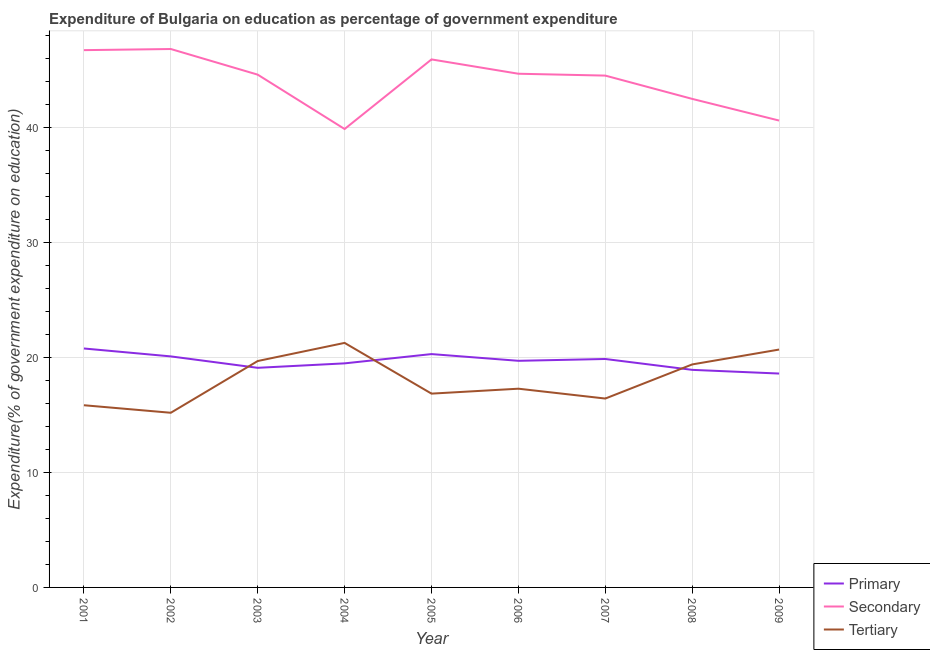What is the expenditure on secondary education in 2006?
Make the answer very short. 44.69. Across all years, what is the maximum expenditure on tertiary education?
Ensure brevity in your answer.  21.27. Across all years, what is the minimum expenditure on secondary education?
Give a very brief answer. 39.88. In which year was the expenditure on secondary education minimum?
Give a very brief answer. 2004. What is the total expenditure on tertiary education in the graph?
Your response must be concise. 162.69. What is the difference between the expenditure on primary education in 2003 and that in 2007?
Offer a terse response. -0.77. What is the difference between the expenditure on tertiary education in 2009 and the expenditure on primary education in 2002?
Your answer should be compact. 0.6. What is the average expenditure on tertiary education per year?
Ensure brevity in your answer.  18.08. In the year 2003, what is the difference between the expenditure on secondary education and expenditure on primary education?
Your response must be concise. 25.5. What is the ratio of the expenditure on primary education in 2004 to that in 2006?
Your answer should be very brief. 0.99. What is the difference between the highest and the second highest expenditure on secondary education?
Provide a short and direct response. 0.1. What is the difference between the highest and the lowest expenditure on tertiary education?
Ensure brevity in your answer.  6.08. Is the sum of the expenditure on secondary education in 2001 and 2007 greater than the maximum expenditure on primary education across all years?
Keep it short and to the point. Yes. Is it the case that in every year, the sum of the expenditure on primary education and expenditure on secondary education is greater than the expenditure on tertiary education?
Provide a succinct answer. Yes. Is the expenditure on tertiary education strictly less than the expenditure on primary education over the years?
Your answer should be very brief. No. How many lines are there?
Your answer should be very brief. 3. How many years are there in the graph?
Your response must be concise. 9. What is the difference between two consecutive major ticks on the Y-axis?
Ensure brevity in your answer.  10. Are the values on the major ticks of Y-axis written in scientific E-notation?
Give a very brief answer. No. Does the graph contain any zero values?
Your answer should be compact. No. Does the graph contain grids?
Provide a short and direct response. Yes. How many legend labels are there?
Offer a terse response. 3. What is the title of the graph?
Give a very brief answer. Expenditure of Bulgaria on education as percentage of government expenditure. What is the label or title of the X-axis?
Your answer should be very brief. Year. What is the label or title of the Y-axis?
Offer a very short reply. Expenditure(% of government expenditure on education). What is the Expenditure(% of government expenditure on education) in Primary in 2001?
Your answer should be compact. 20.79. What is the Expenditure(% of government expenditure on education) of Secondary in 2001?
Your answer should be very brief. 46.74. What is the Expenditure(% of government expenditure on education) of Tertiary in 2001?
Provide a succinct answer. 15.85. What is the Expenditure(% of government expenditure on education) in Primary in 2002?
Make the answer very short. 20.1. What is the Expenditure(% of government expenditure on education) in Secondary in 2002?
Provide a short and direct response. 46.84. What is the Expenditure(% of government expenditure on education) of Tertiary in 2002?
Make the answer very short. 15.19. What is the Expenditure(% of government expenditure on education) of Primary in 2003?
Give a very brief answer. 19.11. What is the Expenditure(% of government expenditure on education) of Secondary in 2003?
Give a very brief answer. 44.61. What is the Expenditure(% of government expenditure on education) of Tertiary in 2003?
Keep it short and to the point. 19.7. What is the Expenditure(% of government expenditure on education) in Primary in 2004?
Ensure brevity in your answer.  19.49. What is the Expenditure(% of government expenditure on education) in Secondary in 2004?
Make the answer very short. 39.88. What is the Expenditure(% of government expenditure on education) of Tertiary in 2004?
Keep it short and to the point. 21.27. What is the Expenditure(% of government expenditure on education) of Primary in 2005?
Offer a terse response. 20.3. What is the Expenditure(% of government expenditure on education) of Secondary in 2005?
Offer a very short reply. 45.94. What is the Expenditure(% of government expenditure on education) of Tertiary in 2005?
Keep it short and to the point. 16.86. What is the Expenditure(% of government expenditure on education) in Primary in 2006?
Your answer should be very brief. 19.72. What is the Expenditure(% of government expenditure on education) of Secondary in 2006?
Your answer should be very brief. 44.69. What is the Expenditure(% of government expenditure on education) of Tertiary in 2006?
Provide a short and direct response. 17.29. What is the Expenditure(% of government expenditure on education) in Primary in 2007?
Your answer should be compact. 19.87. What is the Expenditure(% of government expenditure on education) of Secondary in 2007?
Give a very brief answer. 44.53. What is the Expenditure(% of government expenditure on education) of Tertiary in 2007?
Offer a very short reply. 16.43. What is the Expenditure(% of government expenditure on education) in Primary in 2008?
Your answer should be very brief. 18.93. What is the Expenditure(% of government expenditure on education) in Secondary in 2008?
Your answer should be very brief. 42.5. What is the Expenditure(% of government expenditure on education) of Tertiary in 2008?
Offer a terse response. 19.4. What is the Expenditure(% of government expenditure on education) of Primary in 2009?
Your response must be concise. 18.61. What is the Expenditure(% of government expenditure on education) in Secondary in 2009?
Your response must be concise. 40.62. What is the Expenditure(% of government expenditure on education) of Tertiary in 2009?
Your response must be concise. 20.69. Across all years, what is the maximum Expenditure(% of government expenditure on education) in Primary?
Your answer should be very brief. 20.79. Across all years, what is the maximum Expenditure(% of government expenditure on education) of Secondary?
Your answer should be very brief. 46.84. Across all years, what is the maximum Expenditure(% of government expenditure on education) in Tertiary?
Your answer should be compact. 21.27. Across all years, what is the minimum Expenditure(% of government expenditure on education) in Primary?
Provide a short and direct response. 18.61. Across all years, what is the minimum Expenditure(% of government expenditure on education) in Secondary?
Give a very brief answer. 39.88. Across all years, what is the minimum Expenditure(% of government expenditure on education) of Tertiary?
Provide a short and direct response. 15.19. What is the total Expenditure(% of government expenditure on education) of Primary in the graph?
Provide a succinct answer. 176.91. What is the total Expenditure(% of government expenditure on education) in Secondary in the graph?
Give a very brief answer. 396.34. What is the total Expenditure(% of government expenditure on education) of Tertiary in the graph?
Offer a very short reply. 162.69. What is the difference between the Expenditure(% of government expenditure on education) of Primary in 2001 and that in 2002?
Give a very brief answer. 0.69. What is the difference between the Expenditure(% of government expenditure on education) in Secondary in 2001 and that in 2002?
Offer a terse response. -0.1. What is the difference between the Expenditure(% of government expenditure on education) in Tertiary in 2001 and that in 2002?
Offer a terse response. 0.66. What is the difference between the Expenditure(% of government expenditure on education) of Primary in 2001 and that in 2003?
Keep it short and to the point. 1.68. What is the difference between the Expenditure(% of government expenditure on education) in Secondary in 2001 and that in 2003?
Your answer should be very brief. 2.13. What is the difference between the Expenditure(% of government expenditure on education) in Tertiary in 2001 and that in 2003?
Offer a terse response. -3.85. What is the difference between the Expenditure(% of government expenditure on education) in Primary in 2001 and that in 2004?
Your response must be concise. 1.29. What is the difference between the Expenditure(% of government expenditure on education) in Secondary in 2001 and that in 2004?
Make the answer very short. 6.86. What is the difference between the Expenditure(% of government expenditure on education) of Tertiary in 2001 and that in 2004?
Your answer should be very brief. -5.42. What is the difference between the Expenditure(% of government expenditure on education) in Primary in 2001 and that in 2005?
Offer a very short reply. 0.49. What is the difference between the Expenditure(% of government expenditure on education) in Secondary in 2001 and that in 2005?
Ensure brevity in your answer.  0.81. What is the difference between the Expenditure(% of government expenditure on education) in Tertiary in 2001 and that in 2005?
Your answer should be compact. -1.01. What is the difference between the Expenditure(% of government expenditure on education) in Primary in 2001 and that in 2006?
Offer a very short reply. 1.07. What is the difference between the Expenditure(% of government expenditure on education) in Secondary in 2001 and that in 2006?
Provide a short and direct response. 2.05. What is the difference between the Expenditure(% of government expenditure on education) in Tertiary in 2001 and that in 2006?
Your response must be concise. -1.44. What is the difference between the Expenditure(% of government expenditure on education) of Primary in 2001 and that in 2007?
Offer a very short reply. 0.91. What is the difference between the Expenditure(% of government expenditure on education) in Secondary in 2001 and that in 2007?
Ensure brevity in your answer.  2.21. What is the difference between the Expenditure(% of government expenditure on education) of Tertiary in 2001 and that in 2007?
Your answer should be compact. -0.58. What is the difference between the Expenditure(% of government expenditure on education) of Primary in 2001 and that in 2008?
Your answer should be compact. 1.86. What is the difference between the Expenditure(% of government expenditure on education) of Secondary in 2001 and that in 2008?
Your response must be concise. 4.24. What is the difference between the Expenditure(% of government expenditure on education) in Tertiary in 2001 and that in 2008?
Offer a very short reply. -3.55. What is the difference between the Expenditure(% of government expenditure on education) in Primary in 2001 and that in 2009?
Make the answer very short. 2.18. What is the difference between the Expenditure(% of government expenditure on education) in Secondary in 2001 and that in 2009?
Your response must be concise. 6.13. What is the difference between the Expenditure(% of government expenditure on education) in Tertiary in 2001 and that in 2009?
Ensure brevity in your answer.  -4.84. What is the difference between the Expenditure(% of government expenditure on education) of Primary in 2002 and that in 2003?
Offer a very short reply. 0.99. What is the difference between the Expenditure(% of government expenditure on education) in Secondary in 2002 and that in 2003?
Offer a very short reply. 2.23. What is the difference between the Expenditure(% of government expenditure on education) in Tertiary in 2002 and that in 2003?
Offer a very short reply. -4.5. What is the difference between the Expenditure(% of government expenditure on education) in Primary in 2002 and that in 2004?
Offer a very short reply. 0.61. What is the difference between the Expenditure(% of government expenditure on education) of Secondary in 2002 and that in 2004?
Provide a succinct answer. 6.96. What is the difference between the Expenditure(% of government expenditure on education) in Tertiary in 2002 and that in 2004?
Offer a very short reply. -6.08. What is the difference between the Expenditure(% of government expenditure on education) of Primary in 2002 and that in 2005?
Your answer should be compact. -0.2. What is the difference between the Expenditure(% of government expenditure on education) of Secondary in 2002 and that in 2005?
Offer a very short reply. 0.9. What is the difference between the Expenditure(% of government expenditure on education) in Tertiary in 2002 and that in 2005?
Give a very brief answer. -1.67. What is the difference between the Expenditure(% of government expenditure on education) in Primary in 2002 and that in 2006?
Your answer should be very brief. 0.38. What is the difference between the Expenditure(% of government expenditure on education) of Secondary in 2002 and that in 2006?
Provide a succinct answer. 2.15. What is the difference between the Expenditure(% of government expenditure on education) in Tertiary in 2002 and that in 2006?
Offer a terse response. -2.09. What is the difference between the Expenditure(% of government expenditure on education) in Primary in 2002 and that in 2007?
Your answer should be compact. 0.23. What is the difference between the Expenditure(% of government expenditure on education) of Secondary in 2002 and that in 2007?
Make the answer very short. 2.31. What is the difference between the Expenditure(% of government expenditure on education) in Tertiary in 2002 and that in 2007?
Keep it short and to the point. -1.24. What is the difference between the Expenditure(% of government expenditure on education) in Primary in 2002 and that in 2008?
Your response must be concise. 1.17. What is the difference between the Expenditure(% of government expenditure on education) of Secondary in 2002 and that in 2008?
Make the answer very short. 4.34. What is the difference between the Expenditure(% of government expenditure on education) in Tertiary in 2002 and that in 2008?
Keep it short and to the point. -4.21. What is the difference between the Expenditure(% of government expenditure on education) in Primary in 2002 and that in 2009?
Your response must be concise. 1.49. What is the difference between the Expenditure(% of government expenditure on education) of Secondary in 2002 and that in 2009?
Your answer should be compact. 6.22. What is the difference between the Expenditure(% of government expenditure on education) of Tertiary in 2002 and that in 2009?
Give a very brief answer. -5.5. What is the difference between the Expenditure(% of government expenditure on education) of Primary in 2003 and that in 2004?
Your response must be concise. -0.39. What is the difference between the Expenditure(% of government expenditure on education) in Secondary in 2003 and that in 2004?
Offer a terse response. 4.73. What is the difference between the Expenditure(% of government expenditure on education) in Tertiary in 2003 and that in 2004?
Keep it short and to the point. -1.58. What is the difference between the Expenditure(% of government expenditure on education) in Primary in 2003 and that in 2005?
Give a very brief answer. -1.19. What is the difference between the Expenditure(% of government expenditure on education) in Secondary in 2003 and that in 2005?
Keep it short and to the point. -1.33. What is the difference between the Expenditure(% of government expenditure on education) of Tertiary in 2003 and that in 2005?
Give a very brief answer. 2.84. What is the difference between the Expenditure(% of government expenditure on education) in Primary in 2003 and that in 2006?
Provide a succinct answer. -0.61. What is the difference between the Expenditure(% of government expenditure on education) in Secondary in 2003 and that in 2006?
Make the answer very short. -0.08. What is the difference between the Expenditure(% of government expenditure on education) of Tertiary in 2003 and that in 2006?
Your response must be concise. 2.41. What is the difference between the Expenditure(% of government expenditure on education) in Primary in 2003 and that in 2007?
Keep it short and to the point. -0.77. What is the difference between the Expenditure(% of government expenditure on education) in Secondary in 2003 and that in 2007?
Keep it short and to the point. 0.08. What is the difference between the Expenditure(% of government expenditure on education) of Tertiary in 2003 and that in 2007?
Give a very brief answer. 3.26. What is the difference between the Expenditure(% of government expenditure on education) in Primary in 2003 and that in 2008?
Your response must be concise. 0.18. What is the difference between the Expenditure(% of government expenditure on education) in Secondary in 2003 and that in 2008?
Offer a very short reply. 2.11. What is the difference between the Expenditure(% of government expenditure on education) of Tertiary in 2003 and that in 2008?
Offer a terse response. 0.3. What is the difference between the Expenditure(% of government expenditure on education) of Primary in 2003 and that in 2009?
Provide a succinct answer. 0.5. What is the difference between the Expenditure(% of government expenditure on education) of Secondary in 2003 and that in 2009?
Provide a succinct answer. 3.99. What is the difference between the Expenditure(% of government expenditure on education) in Tertiary in 2003 and that in 2009?
Your answer should be very brief. -1. What is the difference between the Expenditure(% of government expenditure on education) of Primary in 2004 and that in 2005?
Your answer should be compact. -0.81. What is the difference between the Expenditure(% of government expenditure on education) of Secondary in 2004 and that in 2005?
Keep it short and to the point. -6.05. What is the difference between the Expenditure(% of government expenditure on education) in Tertiary in 2004 and that in 2005?
Ensure brevity in your answer.  4.41. What is the difference between the Expenditure(% of government expenditure on education) in Primary in 2004 and that in 2006?
Offer a very short reply. -0.22. What is the difference between the Expenditure(% of government expenditure on education) of Secondary in 2004 and that in 2006?
Keep it short and to the point. -4.81. What is the difference between the Expenditure(% of government expenditure on education) of Tertiary in 2004 and that in 2006?
Provide a short and direct response. 3.98. What is the difference between the Expenditure(% of government expenditure on education) of Primary in 2004 and that in 2007?
Keep it short and to the point. -0.38. What is the difference between the Expenditure(% of government expenditure on education) in Secondary in 2004 and that in 2007?
Provide a succinct answer. -4.65. What is the difference between the Expenditure(% of government expenditure on education) of Tertiary in 2004 and that in 2007?
Your answer should be very brief. 4.84. What is the difference between the Expenditure(% of government expenditure on education) of Primary in 2004 and that in 2008?
Offer a terse response. 0.56. What is the difference between the Expenditure(% of government expenditure on education) in Secondary in 2004 and that in 2008?
Your response must be concise. -2.62. What is the difference between the Expenditure(% of government expenditure on education) in Tertiary in 2004 and that in 2008?
Offer a terse response. 1.87. What is the difference between the Expenditure(% of government expenditure on education) in Primary in 2004 and that in 2009?
Your answer should be very brief. 0.89. What is the difference between the Expenditure(% of government expenditure on education) in Secondary in 2004 and that in 2009?
Provide a short and direct response. -0.74. What is the difference between the Expenditure(% of government expenditure on education) in Tertiary in 2004 and that in 2009?
Provide a succinct answer. 0.58. What is the difference between the Expenditure(% of government expenditure on education) of Primary in 2005 and that in 2006?
Provide a succinct answer. 0.58. What is the difference between the Expenditure(% of government expenditure on education) in Secondary in 2005 and that in 2006?
Keep it short and to the point. 1.25. What is the difference between the Expenditure(% of government expenditure on education) of Tertiary in 2005 and that in 2006?
Make the answer very short. -0.43. What is the difference between the Expenditure(% of government expenditure on education) of Primary in 2005 and that in 2007?
Offer a terse response. 0.43. What is the difference between the Expenditure(% of government expenditure on education) in Secondary in 2005 and that in 2007?
Keep it short and to the point. 1.41. What is the difference between the Expenditure(% of government expenditure on education) in Tertiary in 2005 and that in 2007?
Provide a succinct answer. 0.43. What is the difference between the Expenditure(% of government expenditure on education) in Primary in 2005 and that in 2008?
Provide a short and direct response. 1.37. What is the difference between the Expenditure(% of government expenditure on education) of Secondary in 2005 and that in 2008?
Keep it short and to the point. 3.43. What is the difference between the Expenditure(% of government expenditure on education) of Tertiary in 2005 and that in 2008?
Keep it short and to the point. -2.54. What is the difference between the Expenditure(% of government expenditure on education) in Primary in 2005 and that in 2009?
Ensure brevity in your answer.  1.69. What is the difference between the Expenditure(% of government expenditure on education) of Secondary in 2005 and that in 2009?
Provide a succinct answer. 5.32. What is the difference between the Expenditure(% of government expenditure on education) of Tertiary in 2005 and that in 2009?
Give a very brief answer. -3.83. What is the difference between the Expenditure(% of government expenditure on education) of Primary in 2006 and that in 2007?
Provide a short and direct response. -0.16. What is the difference between the Expenditure(% of government expenditure on education) in Secondary in 2006 and that in 2007?
Make the answer very short. 0.16. What is the difference between the Expenditure(% of government expenditure on education) in Tertiary in 2006 and that in 2007?
Ensure brevity in your answer.  0.86. What is the difference between the Expenditure(% of government expenditure on education) of Primary in 2006 and that in 2008?
Provide a short and direct response. 0.79. What is the difference between the Expenditure(% of government expenditure on education) in Secondary in 2006 and that in 2008?
Your response must be concise. 2.19. What is the difference between the Expenditure(% of government expenditure on education) of Tertiary in 2006 and that in 2008?
Offer a very short reply. -2.11. What is the difference between the Expenditure(% of government expenditure on education) of Primary in 2006 and that in 2009?
Keep it short and to the point. 1.11. What is the difference between the Expenditure(% of government expenditure on education) in Secondary in 2006 and that in 2009?
Your answer should be very brief. 4.07. What is the difference between the Expenditure(% of government expenditure on education) of Tertiary in 2006 and that in 2009?
Your answer should be compact. -3.41. What is the difference between the Expenditure(% of government expenditure on education) in Primary in 2007 and that in 2008?
Provide a short and direct response. 0.95. What is the difference between the Expenditure(% of government expenditure on education) of Secondary in 2007 and that in 2008?
Your answer should be compact. 2.03. What is the difference between the Expenditure(% of government expenditure on education) in Tertiary in 2007 and that in 2008?
Keep it short and to the point. -2.97. What is the difference between the Expenditure(% of government expenditure on education) of Primary in 2007 and that in 2009?
Your response must be concise. 1.27. What is the difference between the Expenditure(% of government expenditure on education) of Secondary in 2007 and that in 2009?
Offer a very short reply. 3.91. What is the difference between the Expenditure(% of government expenditure on education) of Tertiary in 2007 and that in 2009?
Ensure brevity in your answer.  -4.26. What is the difference between the Expenditure(% of government expenditure on education) of Primary in 2008 and that in 2009?
Keep it short and to the point. 0.32. What is the difference between the Expenditure(% of government expenditure on education) in Secondary in 2008 and that in 2009?
Provide a succinct answer. 1.89. What is the difference between the Expenditure(% of government expenditure on education) in Tertiary in 2008 and that in 2009?
Your answer should be very brief. -1.29. What is the difference between the Expenditure(% of government expenditure on education) of Primary in 2001 and the Expenditure(% of government expenditure on education) of Secondary in 2002?
Your response must be concise. -26.05. What is the difference between the Expenditure(% of government expenditure on education) in Primary in 2001 and the Expenditure(% of government expenditure on education) in Tertiary in 2002?
Provide a succinct answer. 5.59. What is the difference between the Expenditure(% of government expenditure on education) in Secondary in 2001 and the Expenditure(% of government expenditure on education) in Tertiary in 2002?
Provide a short and direct response. 31.55. What is the difference between the Expenditure(% of government expenditure on education) of Primary in 2001 and the Expenditure(% of government expenditure on education) of Secondary in 2003?
Your response must be concise. -23.82. What is the difference between the Expenditure(% of government expenditure on education) in Primary in 2001 and the Expenditure(% of government expenditure on education) in Tertiary in 2003?
Your answer should be compact. 1.09. What is the difference between the Expenditure(% of government expenditure on education) of Secondary in 2001 and the Expenditure(% of government expenditure on education) of Tertiary in 2003?
Offer a terse response. 27.05. What is the difference between the Expenditure(% of government expenditure on education) in Primary in 2001 and the Expenditure(% of government expenditure on education) in Secondary in 2004?
Your answer should be very brief. -19.09. What is the difference between the Expenditure(% of government expenditure on education) in Primary in 2001 and the Expenditure(% of government expenditure on education) in Tertiary in 2004?
Your answer should be very brief. -0.49. What is the difference between the Expenditure(% of government expenditure on education) of Secondary in 2001 and the Expenditure(% of government expenditure on education) of Tertiary in 2004?
Your response must be concise. 25.47. What is the difference between the Expenditure(% of government expenditure on education) in Primary in 2001 and the Expenditure(% of government expenditure on education) in Secondary in 2005?
Ensure brevity in your answer.  -25.15. What is the difference between the Expenditure(% of government expenditure on education) of Primary in 2001 and the Expenditure(% of government expenditure on education) of Tertiary in 2005?
Your response must be concise. 3.93. What is the difference between the Expenditure(% of government expenditure on education) in Secondary in 2001 and the Expenditure(% of government expenditure on education) in Tertiary in 2005?
Your answer should be very brief. 29.88. What is the difference between the Expenditure(% of government expenditure on education) in Primary in 2001 and the Expenditure(% of government expenditure on education) in Secondary in 2006?
Ensure brevity in your answer.  -23.9. What is the difference between the Expenditure(% of government expenditure on education) of Primary in 2001 and the Expenditure(% of government expenditure on education) of Tertiary in 2006?
Ensure brevity in your answer.  3.5. What is the difference between the Expenditure(% of government expenditure on education) of Secondary in 2001 and the Expenditure(% of government expenditure on education) of Tertiary in 2006?
Offer a very short reply. 29.45. What is the difference between the Expenditure(% of government expenditure on education) of Primary in 2001 and the Expenditure(% of government expenditure on education) of Secondary in 2007?
Your answer should be compact. -23.74. What is the difference between the Expenditure(% of government expenditure on education) in Primary in 2001 and the Expenditure(% of government expenditure on education) in Tertiary in 2007?
Provide a short and direct response. 4.36. What is the difference between the Expenditure(% of government expenditure on education) in Secondary in 2001 and the Expenditure(% of government expenditure on education) in Tertiary in 2007?
Keep it short and to the point. 30.31. What is the difference between the Expenditure(% of government expenditure on education) in Primary in 2001 and the Expenditure(% of government expenditure on education) in Secondary in 2008?
Offer a terse response. -21.71. What is the difference between the Expenditure(% of government expenditure on education) in Primary in 2001 and the Expenditure(% of government expenditure on education) in Tertiary in 2008?
Provide a succinct answer. 1.39. What is the difference between the Expenditure(% of government expenditure on education) of Secondary in 2001 and the Expenditure(% of government expenditure on education) of Tertiary in 2008?
Your answer should be very brief. 27.34. What is the difference between the Expenditure(% of government expenditure on education) of Primary in 2001 and the Expenditure(% of government expenditure on education) of Secondary in 2009?
Offer a terse response. -19.83. What is the difference between the Expenditure(% of government expenditure on education) of Primary in 2001 and the Expenditure(% of government expenditure on education) of Tertiary in 2009?
Offer a very short reply. 0.09. What is the difference between the Expenditure(% of government expenditure on education) in Secondary in 2001 and the Expenditure(% of government expenditure on education) in Tertiary in 2009?
Offer a very short reply. 26.05. What is the difference between the Expenditure(% of government expenditure on education) in Primary in 2002 and the Expenditure(% of government expenditure on education) in Secondary in 2003?
Keep it short and to the point. -24.51. What is the difference between the Expenditure(% of government expenditure on education) in Primary in 2002 and the Expenditure(% of government expenditure on education) in Tertiary in 2003?
Keep it short and to the point. 0.4. What is the difference between the Expenditure(% of government expenditure on education) in Secondary in 2002 and the Expenditure(% of government expenditure on education) in Tertiary in 2003?
Offer a very short reply. 27.14. What is the difference between the Expenditure(% of government expenditure on education) in Primary in 2002 and the Expenditure(% of government expenditure on education) in Secondary in 2004?
Your answer should be compact. -19.78. What is the difference between the Expenditure(% of government expenditure on education) in Primary in 2002 and the Expenditure(% of government expenditure on education) in Tertiary in 2004?
Make the answer very short. -1.17. What is the difference between the Expenditure(% of government expenditure on education) of Secondary in 2002 and the Expenditure(% of government expenditure on education) of Tertiary in 2004?
Ensure brevity in your answer.  25.57. What is the difference between the Expenditure(% of government expenditure on education) of Primary in 2002 and the Expenditure(% of government expenditure on education) of Secondary in 2005?
Give a very brief answer. -25.84. What is the difference between the Expenditure(% of government expenditure on education) of Primary in 2002 and the Expenditure(% of government expenditure on education) of Tertiary in 2005?
Your answer should be compact. 3.24. What is the difference between the Expenditure(% of government expenditure on education) of Secondary in 2002 and the Expenditure(% of government expenditure on education) of Tertiary in 2005?
Offer a terse response. 29.98. What is the difference between the Expenditure(% of government expenditure on education) in Primary in 2002 and the Expenditure(% of government expenditure on education) in Secondary in 2006?
Give a very brief answer. -24.59. What is the difference between the Expenditure(% of government expenditure on education) in Primary in 2002 and the Expenditure(% of government expenditure on education) in Tertiary in 2006?
Give a very brief answer. 2.81. What is the difference between the Expenditure(% of government expenditure on education) of Secondary in 2002 and the Expenditure(% of government expenditure on education) of Tertiary in 2006?
Your answer should be compact. 29.55. What is the difference between the Expenditure(% of government expenditure on education) in Primary in 2002 and the Expenditure(% of government expenditure on education) in Secondary in 2007?
Provide a succinct answer. -24.43. What is the difference between the Expenditure(% of government expenditure on education) in Primary in 2002 and the Expenditure(% of government expenditure on education) in Tertiary in 2007?
Provide a short and direct response. 3.67. What is the difference between the Expenditure(% of government expenditure on education) of Secondary in 2002 and the Expenditure(% of government expenditure on education) of Tertiary in 2007?
Provide a short and direct response. 30.41. What is the difference between the Expenditure(% of government expenditure on education) of Primary in 2002 and the Expenditure(% of government expenditure on education) of Secondary in 2008?
Your response must be concise. -22.4. What is the difference between the Expenditure(% of government expenditure on education) of Primary in 2002 and the Expenditure(% of government expenditure on education) of Tertiary in 2008?
Your response must be concise. 0.7. What is the difference between the Expenditure(% of government expenditure on education) in Secondary in 2002 and the Expenditure(% of government expenditure on education) in Tertiary in 2008?
Your response must be concise. 27.44. What is the difference between the Expenditure(% of government expenditure on education) in Primary in 2002 and the Expenditure(% of government expenditure on education) in Secondary in 2009?
Provide a succinct answer. -20.52. What is the difference between the Expenditure(% of government expenditure on education) of Primary in 2002 and the Expenditure(% of government expenditure on education) of Tertiary in 2009?
Provide a succinct answer. -0.6. What is the difference between the Expenditure(% of government expenditure on education) in Secondary in 2002 and the Expenditure(% of government expenditure on education) in Tertiary in 2009?
Your answer should be compact. 26.15. What is the difference between the Expenditure(% of government expenditure on education) in Primary in 2003 and the Expenditure(% of government expenditure on education) in Secondary in 2004?
Your answer should be compact. -20.77. What is the difference between the Expenditure(% of government expenditure on education) in Primary in 2003 and the Expenditure(% of government expenditure on education) in Tertiary in 2004?
Keep it short and to the point. -2.17. What is the difference between the Expenditure(% of government expenditure on education) of Secondary in 2003 and the Expenditure(% of government expenditure on education) of Tertiary in 2004?
Your answer should be compact. 23.34. What is the difference between the Expenditure(% of government expenditure on education) in Primary in 2003 and the Expenditure(% of government expenditure on education) in Secondary in 2005?
Keep it short and to the point. -26.83. What is the difference between the Expenditure(% of government expenditure on education) of Primary in 2003 and the Expenditure(% of government expenditure on education) of Tertiary in 2005?
Offer a terse response. 2.25. What is the difference between the Expenditure(% of government expenditure on education) in Secondary in 2003 and the Expenditure(% of government expenditure on education) in Tertiary in 2005?
Your answer should be very brief. 27.75. What is the difference between the Expenditure(% of government expenditure on education) in Primary in 2003 and the Expenditure(% of government expenditure on education) in Secondary in 2006?
Ensure brevity in your answer.  -25.58. What is the difference between the Expenditure(% of government expenditure on education) in Primary in 2003 and the Expenditure(% of government expenditure on education) in Tertiary in 2006?
Provide a short and direct response. 1.82. What is the difference between the Expenditure(% of government expenditure on education) in Secondary in 2003 and the Expenditure(% of government expenditure on education) in Tertiary in 2006?
Make the answer very short. 27.32. What is the difference between the Expenditure(% of government expenditure on education) in Primary in 2003 and the Expenditure(% of government expenditure on education) in Secondary in 2007?
Offer a terse response. -25.42. What is the difference between the Expenditure(% of government expenditure on education) in Primary in 2003 and the Expenditure(% of government expenditure on education) in Tertiary in 2007?
Offer a terse response. 2.67. What is the difference between the Expenditure(% of government expenditure on education) of Secondary in 2003 and the Expenditure(% of government expenditure on education) of Tertiary in 2007?
Offer a terse response. 28.18. What is the difference between the Expenditure(% of government expenditure on education) in Primary in 2003 and the Expenditure(% of government expenditure on education) in Secondary in 2008?
Make the answer very short. -23.4. What is the difference between the Expenditure(% of government expenditure on education) in Primary in 2003 and the Expenditure(% of government expenditure on education) in Tertiary in 2008?
Your response must be concise. -0.29. What is the difference between the Expenditure(% of government expenditure on education) in Secondary in 2003 and the Expenditure(% of government expenditure on education) in Tertiary in 2008?
Your answer should be compact. 25.21. What is the difference between the Expenditure(% of government expenditure on education) in Primary in 2003 and the Expenditure(% of government expenditure on education) in Secondary in 2009?
Provide a succinct answer. -21.51. What is the difference between the Expenditure(% of government expenditure on education) of Primary in 2003 and the Expenditure(% of government expenditure on education) of Tertiary in 2009?
Offer a terse response. -1.59. What is the difference between the Expenditure(% of government expenditure on education) of Secondary in 2003 and the Expenditure(% of government expenditure on education) of Tertiary in 2009?
Provide a succinct answer. 23.92. What is the difference between the Expenditure(% of government expenditure on education) in Primary in 2004 and the Expenditure(% of government expenditure on education) in Secondary in 2005?
Provide a succinct answer. -26.44. What is the difference between the Expenditure(% of government expenditure on education) in Primary in 2004 and the Expenditure(% of government expenditure on education) in Tertiary in 2005?
Make the answer very short. 2.63. What is the difference between the Expenditure(% of government expenditure on education) of Secondary in 2004 and the Expenditure(% of government expenditure on education) of Tertiary in 2005?
Provide a short and direct response. 23.02. What is the difference between the Expenditure(% of government expenditure on education) of Primary in 2004 and the Expenditure(% of government expenditure on education) of Secondary in 2006?
Ensure brevity in your answer.  -25.2. What is the difference between the Expenditure(% of government expenditure on education) in Primary in 2004 and the Expenditure(% of government expenditure on education) in Tertiary in 2006?
Provide a short and direct response. 2.2. What is the difference between the Expenditure(% of government expenditure on education) in Secondary in 2004 and the Expenditure(% of government expenditure on education) in Tertiary in 2006?
Make the answer very short. 22.59. What is the difference between the Expenditure(% of government expenditure on education) of Primary in 2004 and the Expenditure(% of government expenditure on education) of Secondary in 2007?
Offer a very short reply. -25.04. What is the difference between the Expenditure(% of government expenditure on education) in Primary in 2004 and the Expenditure(% of government expenditure on education) in Tertiary in 2007?
Give a very brief answer. 3.06. What is the difference between the Expenditure(% of government expenditure on education) in Secondary in 2004 and the Expenditure(% of government expenditure on education) in Tertiary in 2007?
Provide a short and direct response. 23.45. What is the difference between the Expenditure(% of government expenditure on education) of Primary in 2004 and the Expenditure(% of government expenditure on education) of Secondary in 2008?
Make the answer very short. -23.01. What is the difference between the Expenditure(% of government expenditure on education) in Primary in 2004 and the Expenditure(% of government expenditure on education) in Tertiary in 2008?
Ensure brevity in your answer.  0.09. What is the difference between the Expenditure(% of government expenditure on education) in Secondary in 2004 and the Expenditure(% of government expenditure on education) in Tertiary in 2008?
Your response must be concise. 20.48. What is the difference between the Expenditure(% of government expenditure on education) in Primary in 2004 and the Expenditure(% of government expenditure on education) in Secondary in 2009?
Offer a terse response. -21.12. What is the difference between the Expenditure(% of government expenditure on education) of Primary in 2004 and the Expenditure(% of government expenditure on education) of Tertiary in 2009?
Provide a succinct answer. -1.2. What is the difference between the Expenditure(% of government expenditure on education) of Secondary in 2004 and the Expenditure(% of government expenditure on education) of Tertiary in 2009?
Provide a short and direct response. 19.19. What is the difference between the Expenditure(% of government expenditure on education) of Primary in 2005 and the Expenditure(% of government expenditure on education) of Secondary in 2006?
Give a very brief answer. -24.39. What is the difference between the Expenditure(% of government expenditure on education) of Primary in 2005 and the Expenditure(% of government expenditure on education) of Tertiary in 2006?
Give a very brief answer. 3.01. What is the difference between the Expenditure(% of government expenditure on education) of Secondary in 2005 and the Expenditure(% of government expenditure on education) of Tertiary in 2006?
Offer a terse response. 28.65. What is the difference between the Expenditure(% of government expenditure on education) in Primary in 2005 and the Expenditure(% of government expenditure on education) in Secondary in 2007?
Provide a succinct answer. -24.23. What is the difference between the Expenditure(% of government expenditure on education) of Primary in 2005 and the Expenditure(% of government expenditure on education) of Tertiary in 2007?
Offer a terse response. 3.87. What is the difference between the Expenditure(% of government expenditure on education) in Secondary in 2005 and the Expenditure(% of government expenditure on education) in Tertiary in 2007?
Provide a succinct answer. 29.5. What is the difference between the Expenditure(% of government expenditure on education) in Primary in 2005 and the Expenditure(% of government expenditure on education) in Secondary in 2008?
Give a very brief answer. -22.2. What is the difference between the Expenditure(% of government expenditure on education) of Primary in 2005 and the Expenditure(% of government expenditure on education) of Tertiary in 2008?
Keep it short and to the point. 0.9. What is the difference between the Expenditure(% of government expenditure on education) of Secondary in 2005 and the Expenditure(% of government expenditure on education) of Tertiary in 2008?
Your response must be concise. 26.54. What is the difference between the Expenditure(% of government expenditure on education) of Primary in 2005 and the Expenditure(% of government expenditure on education) of Secondary in 2009?
Offer a terse response. -20.32. What is the difference between the Expenditure(% of government expenditure on education) of Primary in 2005 and the Expenditure(% of government expenditure on education) of Tertiary in 2009?
Your answer should be compact. -0.39. What is the difference between the Expenditure(% of government expenditure on education) in Secondary in 2005 and the Expenditure(% of government expenditure on education) in Tertiary in 2009?
Keep it short and to the point. 25.24. What is the difference between the Expenditure(% of government expenditure on education) in Primary in 2006 and the Expenditure(% of government expenditure on education) in Secondary in 2007?
Ensure brevity in your answer.  -24.81. What is the difference between the Expenditure(% of government expenditure on education) of Primary in 2006 and the Expenditure(% of government expenditure on education) of Tertiary in 2007?
Your answer should be compact. 3.28. What is the difference between the Expenditure(% of government expenditure on education) in Secondary in 2006 and the Expenditure(% of government expenditure on education) in Tertiary in 2007?
Your answer should be compact. 28.26. What is the difference between the Expenditure(% of government expenditure on education) in Primary in 2006 and the Expenditure(% of government expenditure on education) in Secondary in 2008?
Make the answer very short. -22.79. What is the difference between the Expenditure(% of government expenditure on education) of Primary in 2006 and the Expenditure(% of government expenditure on education) of Tertiary in 2008?
Offer a very short reply. 0.32. What is the difference between the Expenditure(% of government expenditure on education) of Secondary in 2006 and the Expenditure(% of government expenditure on education) of Tertiary in 2008?
Offer a terse response. 25.29. What is the difference between the Expenditure(% of government expenditure on education) in Primary in 2006 and the Expenditure(% of government expenditure on education) in Secondary in 2009?
Offer a terse response. -20.9. What is the difference between the Expenditure(% of government expenditure on education) in Primary in 2006 and the Expenditure(% of government expenditure on education) in Tertiary in 2009?
Ensure brevity in your answer.  -0.98. What is the difference between the Expenditure(% of government expenditure on education) in Secondary in 2006 and the Expenditure(% of government expenditure on education) in Tertiary in 2009?
Give a very brief answer. 23.99. What is the difference between the Expenditure(% of government expenditure on education) of Primary in 2007 and the Expenditure(% of government expenditure on education) of Secondary in 2008?
Provide a succinct answer. -22.63. What is the difference between the Expenditure(% of government expenditure on education) of Primary in 2007 and the Expenditure(% of government expenditure on education) of Tertiary in 2008?
Give a very brief answer. 0.47. What is the difference between the Expenditure(% of government expenditure on education) of Secondary in 2007 and the Expenditure(% of government expenditure on education) of Tertiary in 2008?
Your response must be concise. 25.13. What is the difference between the Expenditure(% of government expenditure on education) in Primary in 2007 and the Expenditure(% of government expenditure on education) in Secondary in 2009?
Ensure brevity in your answer.  -20.74. What is the difference between the Expenditure(% of government expenditure on education) of Primary in 2007 and the Expenditure(% of government expenditure on education) of Tertiary in 2009?
Provide a short and direct response. -0.82. What is the difference between the Expenditure(% of government expenditure on education) of Secondary in 2007 and the Expenditure(% of government expenditure on education) of Tertiary in 2009?
Your response must be concise. 23.83. What is the difference between the Expenditure(% of government expenditure on education) in Primary in 2008 and the Expenditure(% of government expenditure on education) in Secondary in 2009?
Your answer should be compact. -21.69. What is the difference between the Expenditure(% of government expenditure on education) in Primary in 2008 and the Expenditure(% of government expenditure on education) in Tertiary in 2009?
Keep it short and to the point. -1.77. What is the difference between the Expenditure(% of government expenditure on education) in Secondary in 2008 and the Expenditure(% of government expenditure on education) in Tertiary in 2009?
Your answer should be very brief. 21.81. What is the average Expenditure(% of government expenditure on education) in Primary per year?
Give a very brief answer. 19.66. What is the average Expenditure(% of government expenditure on education) in Secondary per year?
Your answer should be compact. 44.04. What is the average Expenditure(% of government expenditure on education) in Tertiary per year?
Keep it short and to the point. 18.08. In the year 2001, what is the difference between the Expenditure(% of government expenditure on education) in Primary and Expenditure(% of government expenditure on education) in Secondary?
Ensure brevity in your answer.  -25.96. In the year 2001, what is the difference between the Expenditure(% of government expenditure on education) in Primary and Expenditure(% of government expenditure on education) in Tertiary?
Keep it short and to the point. 4.94. In the year 2001, what is the difference between the Expenditure(% of government expenditure on education) of Secondary and Expenditure(% of government expenditure on education) of Tertiary?
Ensure brevity in your answer.  30.89. In the year 2002, what is the difference between the Expenditure(% of government expenditure on education) of Primary and Expenditure(% of government expenditure on education) of Secondary?
Provide a short and direct response. -26.74. In the year 2002, what is the difference between the Expenditure(% of government expenditure on education) in Primary and Expenditure(% of government expenditure on education) in Tertiary?
Give a very brief answer. 4.9. In the year 2002, what is the difference between the Expenditure(% of government expenditure on education) in Secondary and Expenditure(% of government expenditure on education) in Tertiary?
Make the answer very short. 31.65. In the year 2003, what is the difference between the Expenditure(% of government expenditure on education) of Primary and Expenditure(% of government expenditure on education) of Secondary?
Make the answer very short. -25.5. In the year 2003, what is the difference between the Expenditure(% of government expenditure on education) in Primary and Expenditure(% of government expenditure on education) in Tertiary?
Give a very brief answer. -0.59. In the year 2003, what is the difference between the Expenditure(% of government expenditure on education) in Secondary and Expenditure(% of government expenditure on education) in Tertiary?
Make the answer very short. 24.91. In the year 2004, what is the difference between the Expenditure(% of government expenditure on education) in Primary and Expenditure(% of government expenditure on education) in Secondary?
Offer a very short reply. -20.39. In the year 2004, what is the difference between the Expenditure(% of government expenditure on education) in Primary and Expenditure(% of government expenditure on education) in Tertiary?
Offer a very short reply. -1.78. In the year 2004, what is the difference between the Expenditure(% of government expenditure on education) of Secondary and Expenditure(% of government expenditure on education) of Tertiary?
Your answer should be compact. 18.61. In the year 2005, what is the difference between the Expenditure(% of government expenditure on education) in Primary and Expenditure(% of government expenditure on education) in Secondary?
Make the answer very short. -25.64. In the year 2005, what is the difference between the Expenditure(% of government expenditure on education) of Primary and Expenditure(% of government expenditure on education) of Tertiary?
Provide a short and direct response. 3.44. In the year 2005, what is the difference between the Expenditure(% of government expenditure on education) in Secondary and Expenditure(% of government expenditure on education) in Tertiary?
Your answer should be very brief. 29.08. In the year 2006, what is the difference between the Expenditure(% of government expenditure on education) of Primary and Expenditure(% of government expenditure on education) of Secondary?
Your answer should be very brief. -24.97. In the year 2006, what is the difference between the Expenditure(% of government expenditure on education) in Primary and Expenditure(% of government expenditure on education) in Tertiary?
Offer a very short reply. 2.43. In the year 2006, what is the difference between the Expenditure(% of government expenditure on education) in Secondary and Expenditure(% of government expenditure on education) in Tertiary?
Offer a terse response. 27.4. In the year 2007, what is the difference between the Expenditure(% of government expenditure on education) of Primary and Expenditure(% of government expenditure on education) of Secondary?
Offer a very short reply. -24.66. In the year 2007, what is the difference between the Expenditure(% of government expenditure on education) of Primary and Expenditure(% of government expenditure on education) of Tertiary?
Make the answer very short. 3.44. In the year 2007, what is the difference between the Expenditure(% of government expenditure on education) in Secondary and Expenditure(% of government expenditure on education) in Tertiary?
Your answer should be very brief. 28.1. In the year 2008, what is the difference between the Expenditure(% of government expenditure on education) of Primary and Expenditure(% of government expenditure on education) of Secondary?
Make the answer very short. -23.57. In the year 2008, what is the difference between the Expenditure(% of government expenditure on education) of Primary and Expenditure(% of government expenditure on education) of Tertiary?
Offer a very short reply. -0.47. In the year 2008, what is the difference between the Expenditure(% of government expenditure on education) in Secondary and Expenditure(% of government expenditure on education) in Tertiary?
Ensure brevity in your answer.  23.1. In the year 2009, what is the difference between the Expenditure(% of government expenditure on education) in Primary and Expenditure(% of government expenditure on education) in Secondary?
Your response must be concise. -22.01. In the year 2009, what is the difference between the Expenditure(% of government expenditure on education) of Primary and Expenditure(% of government expenditure on education) of Tertiary?
Make the answer very short. -2.09. In the year 2009, what is the difference between the Expenditure(% of government expenditure on education) of Secondary and Expenditure(% of government expenditure on education) of Tertiary?
Keep it short and to the point. 19.92. What is the ratio of the Expenditure(% of government expenditure on education) of Primary in 2001 to that in 2002?
Provide a succinct answer. 1.03. What is the ratio of the Expenditure(% of government expenditure on education) in Tertiary in 2001 to that in 2002?
Your answer should be compact. 1.04. What is the ratio of the Expenditure(% of government expenditure on education) of Primary in 2001 to that in 2003?
Offer a terse response. 1.09. What is the ratio of the Expenditure(% of government expenditure on education) of Secondary in 2001 to that in 2003?
Give a very brief answer. 1.05. What is the ratio of the Expenditure(% of government expenditure on education) of Tertiary in 2001 to that in 2003?
Keep it short and to the point. 0.8. What is the ratio of the Expenditure(% of government expenditure on education) in Primary in 2001 to that in 2004?
Offer a terse response. 1.07. What is the ratio of the Expenditure(% of government expenditure on education) in Secondary in 2001 to that in 2004?
Your answer should be compact. 1.17. What is the ratio of the Expenditure(% of government expenditure on education) in Tertiary in 2001 to that in 2004?
Offer a very short reply. 0.75. What is the ratio of the Expenditure(% of government expenditure on education) in Primary in 2001 to that in 2005?
Make the answer very short. 1.02. What is the ratio of the Expenditure(% of government expenditure on education) in Secondary in 2001 to that in 2005?
Ensure brevity in your answer.  1.02. What is the ratio of the Expenditure(% of government expenditure on education) of Tertiary in 2001 to that in 2005?
Offer a very short reply. 0.94. What is the ratio of the Expenditure(% of government expenditure on education) of Primary in 2001 to that in 2006?
Offer a terse response. 1.05. What is the ratio of the Expenditure(% of government expenditure on education) in Secondary in 2001 to that in 2006?
Offer a very short reply. 1.05. What is the ratio of the Expenditure(% of government expenditure on education) of Tertiary in 2001 to that in 2006?
Your answer should be compact. 0.92. What is the ratio of the Expenditure(% of government expenditure on education) in Primary in 2001 to that in 2007?
Offer a terse response. 1.05. What is the ratio of the Expenditure(% of government expenditure on education) of Secondary in 2001 to that in 2007?
Provide a succinct answer. 1.05. What is the ratio of the Expenditure(% of government expenditure on education) of Tertiary in 2001 to that in 2007?
Provide a short and direct response. 0.96. What is the ratio of the Expenditure(% of government expenditure on education) in Primary in 2001 to that in 2008?
Your answer should be compact. 1.1. What is the ratio of the Expenditure(% of government expenditure on education) in Secondary in 2001 to that in 2008?
Make the answer very short. 1.1. What is the ratio of the Expenditure(% of government expenditure on education) of Tertiary in 2001 to that in 2008?
Provide a short and direct response. 0.82. What is the ratio of the Expenditure(% of government expenditure on education) of Primary in 2001 to that in 2009?
Ensure brevity in your answer.  1.12. What is the ratio of the Expenditure(% of government expenditure on education) of Secondary in 2001 to that in 2009?
Your answer should be compact. 1.15. What is the ratio of the Expenditure(% of government expenditure on education) of Tertiary in 2001 to that in 2009?
Your response must be concise. 0.77. What is the ratio of the Expenditure(% of government expenditure on education) in Primary in 2002 to that in 2003?
Offer a terse response. 1.05. What is the ratio of the Expenditure(% of government expenditure on education) in Secondary in 2002 to that in 2003?
Offer a terse response. 1.05. What is the ratio of the Expenditure(% of government expenditure on education) in Tertiary in 2002 to that in 2003?
Provide a succinct answer. 0.77. What is the ratio of the Expenditure(% of government expenditure on education) of Primary in 2002 to that in 2004?
Offer a very short reply. 1.03. What is the ratio of the Expenditure(% of government expenditure on education) in Secondary in 2002 to that in 2004?
Keep it short and to the point. 1.17. What is the ratio of the Expenditure(% of government expenditure on education) in Tertiary in 2002 to that in 2004?
Keep it short and to the point. 0.71. What is the ratio of the Expenditure(% of government expenditure on education) of Primary in 2002 to that in 2005?
Ensure brevity in your answer.  0.99. What is the ratio of the Expenditure(% of government expenditure on education) of Secondary in 2002 to that in 2005?
Your answer should be very brief. 1.02. What is the ratio of the Expenditure(% of government expenditure on education) in Tertiary in 2002 to that in 2005?
Offer a terse response. 0.9. What is the ratio of the Expenditure(% of government expenditure on education) in Primary in 2002 to that in 2006?
Ensure brevity in your answer.  1.02. What is the ratio of the Expenditure(% of government expenditure on education) of Secondary in 2002 to that in 2006?
Provide a succinct answer. 1.05. What is the ratio of the Expenditure(% of government expenditure on education) of Tertiary in 2002 to that in 2006?
Provide a short and direct response. 0.88. What is the ratio of the Expenditure(% of government expenditure on education) in Primary in 2002 to that in 2007?
Make the answer very short. 1.01. What is the ratio of the Expenditure(% of government expenditure on education) in Secondary in 2002 to that in 2007?
Provide a short and direct response. 1.05. What is the ratio of the Expenditure(% of government expenditure on education) in Tertiary in 2002 to that in 2007?
Offer a very short reply. 0.92. What is the ratio of the Expenditure(% of government expenditure on education) of Primary in 2002 to that in 2008?
Keep it short and to the point. 1.06. What is the ratio of the Expenditure(% of government expenditure on education) of Secondary in 2002 to that in 2008?
Your answer should be compact. 1.1. What is the ratio of the Expenditure(% of government expenditure on education) in Tertiary in 2002 to that in 2008?
Your answer should be very brief. 0.78. What is the ratio of the Expenditure(% of government expenditure on education) of Primary in 2002 to that in 2009?
Ensure brevity in your answer.  1.08. What is the ratio of the Expenditure(% of government expenditure on education) in Secondary in 2002 to that in 2009?
Give a very brief answer. 1.15. What is the ratio of the Expenditure(% of government expenditure on education) of Tertiary in 2002 to that in 2009?
Make the answer very short. 0.73. What is the ratio of the Expenditure(% of government expenditure on education) of Primary in 2003 to that in 2004?
Make the answer very short. 0.98. What is the ratio of the Expenditure(% of government expenditure on education) in Secondary in 2003 to that in 2004?
Your answer should be compact. 1.12. What is the ratio of the Expenditure(% of government expenditure on education) in Tertiary in 2003 to that in 2004?
Offer a very short reply. 0.93. What is the ratio of the Expenditure(% of government expenditure on education) in Primary in 2003 to that in 2005?
Your answer should be very brief. 0.94. What is the ratio of the Expenditure(% of government expenditure on education) in Secondary in 2003 to that in 2005?
Provide a short and direct response. 0.97. What is the ratio of the Expenditure(% of government expenditure on education) in Tertiary in 2003 to that in 2005?
Your response must be concise. 1.17. What is the ratio of the Expenditure(% of government expenditure on education) of Primary in 2003 to that in 2006?
Offer a terse response. 0.97. What is the ratio of the Expenditure(% of government expenditure on education) in Secondary in 2003 to that in 2006?
Provide a succinct answer. 1. What is the ratio of the Expenditure(% of government expenditure on education) of Tertiary in 2003 to that in 2006?
Give a very brief answer. 1.14. What is the ratio of the Expenditure(% of government expenditure on education) of Primary in 2003 to that in 2007?
Keep it short and to the point. 0.96. What is the ratio of the Expenditure(% of government expenditure on education) in Secondary in 2003 to that in 2007?
Make the answer very short. 1. What is the ratio of the Expenditure(% of government expenditure on education) in Tertiary in 2003 to that in 2007?
Offer a terse response. 1.2. What is the ratio of the Expenditure(% of government expenditure on education) in Primary in 2003 to that in 2008?
Provide a short and direct response. 1.01. What is the ratio of the Expenditure(% of government expenditure on education) of Secondary in 2003 to that in 2008?
Ensure brevity in your answer.  1.05. What is the ratio of the Expenditure(% of government expenditure on education) in Tertiary in 2003 to that in 2008?
Ensure brevity in your answer.  1.02. What is the ratio of the Expenditure(% of government expenditure on education) in Primary in 2003 to that in 2009?
Keep it short and to the point. 1.03. What is the ratio of the Expenditure(% of government expenditure on education) in Secondary in 2003 to that in 2009?
Offer a very short reply. 1.1. What is the ratio of the Expenditure(% of government expenditure on education) in Tertiary in 2003 to that in 2009?
Give a very brief answer. 0.95. What is the ratio of the Expenditure(% of government expenditure on education) in Primary in 2004 to that in 2005?
Give a very brief answer. 0.96. What is the ratio of the Expenditure(% of government expenditure on education) of Secondary in 2004 to that in 2005?
Your response must be concise. 0.87. What is the ratio of the Expenditure(% of government expenditure on education) of Tertiary in 2004 to that in 2005?
Your response must be concise. 1.26. What is the ratio of the Expenditure(% of government expenditure on education) in Primary in 2004 to that in 2006?
Offer a terse response. 0.99. What is the ratio of the Expenditure(% of government expenditure on education) in Secondary in 2004 to that in 2006?
Provide a short and direct response. 0.89. What is the ratio of the Expenditure(% of government expenditure on education) in Tertiary in 2004 to that in 2006?
Provide a succinct answer. 1.23. What is the ratio of the Expenditure(% of government expenditure on education) in Primary in 2004 to that in 2007?
Offer a terse response. 0.98. What is the ratio of the Expenditure(% of government expenditure on education) in Secondary in 2004 to that in 2007?
Provide a short and direct response. 0.9. What is the ratio of the Expenditure(% of government expenditure on education) in Tertiary in 2004 to that in 2007?
Your response must be concise. 1.29. What is the ratio of the Expenditure(% of government expenditure on education) in Primary in 2004 to that in 2008?
Give a very brief answer. 1.03. What is the ratio of the Expenditure(% of government expenditure on education) in Secondary in 2004 to that in 2008?
Make the answer very short. 0.94. What is the ratio of the Expenditure(% of government expenditure on education) of Tertiary in 2004 to that in 2008?
Your response must be concise. 1.1. What is the ratio of the Expenditure(% of government expenditure on education) of Primary in 2004 to that in 2009?
Offer a terse response. 1.05. What is the ratio of the Expenditure(% of government expenditure on education) in Secondary in 2004 to that in 2009?
Your answer should be compact. 0.98. What is the ratio of the Expenditure(% of government expenditure on education) of Tertiary in 2004 to that in 2009?
Provide a short and direct response. 1.03. What is the ratio of the Expenditure(% of government expenditure on education) of Primary in 2005 to that in 2006?
Your answer should be compact. 1.03. What is the ratio of the Expenditure(% of government expenditure on education) in Secondary in 2005 to that in 2006?
Your response must be concise. 1.03. What is the ratio of the Expenditure(% of government expenditure on education) of Tertiary in 2005 to that in 2006?
Offer a very short reply. 0.98. What is the ratio of the Expenditure(% of government expenditure on education) in Primary in 2005 to that in 2007?
Your answer should be very brief. 1.02. What is the ratio of the Expenditure(% of government expenditure on education) of Secondary in 2005 to that in 2007?
Provide a succinct answer. 1.03. What is the ratio of the Expenditure(% of government expenditure on education) of Tertiary in 2005 to that in 2007?
Ensure brevity in your answer.  1.03. What is the ratio of the Expenditure(% of government expenditure on education) of Primary in 2005 to that in 2008?
Offer a terse response. 1.07. What is the ratio of the Expenditure(% of government expenditure on education) of Secondary in 2005 to that in 2008?
Provide a succinct answer. 1.08. What is the ratio of the Expenditure(% of government expenditure on education) in Tertiary in 2005 to that in 2008?
Give a very brief answer. 0.87. What is the ratio of the Expenditure(% of government expenditure on education) of Primary in 2005 to that in 2009?
Ensure brevity in your answer.  1.09. What is the ratio of the Expenditure(% of government expenditure on education) of Secondary in 2005 to that in 2009?
Keep it short and to the point. 1.13. What is the ratio of the Expenditure(% of government expenditure on education) in Tertiary in 2005 to that in 2009?
Your answer should be very brief. 0.81. What is the ratio of the Expenditure(% of government expenditure on education) in Primary in 2006 to that in 2007?
Offer a terse response. 0.99. What is the ratio of the Expenditure(% of government expenditure on education) of Tertiary in 2006 to that in 2007?
Keep it short and to the point. 1.05. What is the ratio of the Expenditure(% of government expenditure on education) in Primary in 2006 to that in 2008?
Your answer should be compact. 1.04. What is the ratio of the Expenditure(% of government expenditure on education) in Secondary in 2006 to that in 2008?
Offer a terse response. 1.05. What is the ratio of the Expenditure(% of government expenditure on education) in Tertiary in 2006 to that in 2008?
Your answer should be compact. 0.89. What is the ratio of the Expenditure(% of government expenditure on education) in Primary in 2006 to that in 2009?
Offer a terse response. 1.06. What is the ratio of the Expenditure(% of government expenditure on education) in Secondary in 2006 to that in 2009?
Ensure brevity in your answer.  1.1. What is the ratio of the Expenditure(% of government expenditure on education) in Tertiary in 2006 to that in 2009?
Provide a short and direct response. 0.84. What is the ratio of the Expenditure(% of government expenditure on education) of Primary in 2007 to that in 2008?
Give a very brief answer. 1.05. What is the ratio of the Expenditure(% of government expenditure on education) in Secondary in 2007 to that in 2008?
Provide a succinct answer. 1.05. What is the ratio of the Expenditure(% of government expenditure on education) in Tertiary in 2007 to that in 2008?
Offer a terse response. 0.85. What is the ratio of the Expenditure(% of government expenditure on education) of Primary in 2007 to that in 2009?
Your answer should be compact. 1.07. What is the ratio of the Expenditure(% of government expenditure on education) in Secondary in 2007 to that in 2009?
Provide a succinct answer. 1.1. What is the ratio of the Expenditure(% of government expenditure on education) of Tertiary in 2007 to that in 2009?
Make the answer very short. 0.79. What is the ratio of the Expenditure(% of government expenditure on education) in Primary in 2008 to that in 2009?
Your response must be concise. 1.02. What is the ratio of the Expenditure(% of government expenditure on education) in Secondary in 2008 to that in 2009?
Your response must be concise. 1.05. What is the difference between the highest and the second highest Expenditure(% of government expenditure on education) of Primary?
Your answer should be compact. 0.49. What is the difference between the highest and the second highest Expenditure(% of government expenditure on education) of Secondary?
Make the answer very short. 0.1. What is the difference between the highest and the second highest Expenditure(% of government expenditure on education) in Tertiary?
Offer a very short reply. 0.58. What is the difference between the highest and the lowest Expenditure(% of government expenditure on education) in Primary?
Provide a short and direct response. 2.18. What is the difference between the highest and the lowest Expenditure(% of government expenditure on education) in Secondary?
Keep it short and to the point. 6.96. What is the difference between the highest and the lowest Expenditure(% of government expenditure on education) in Tertiary?
Ensure brevity in your answer.  6.08. 